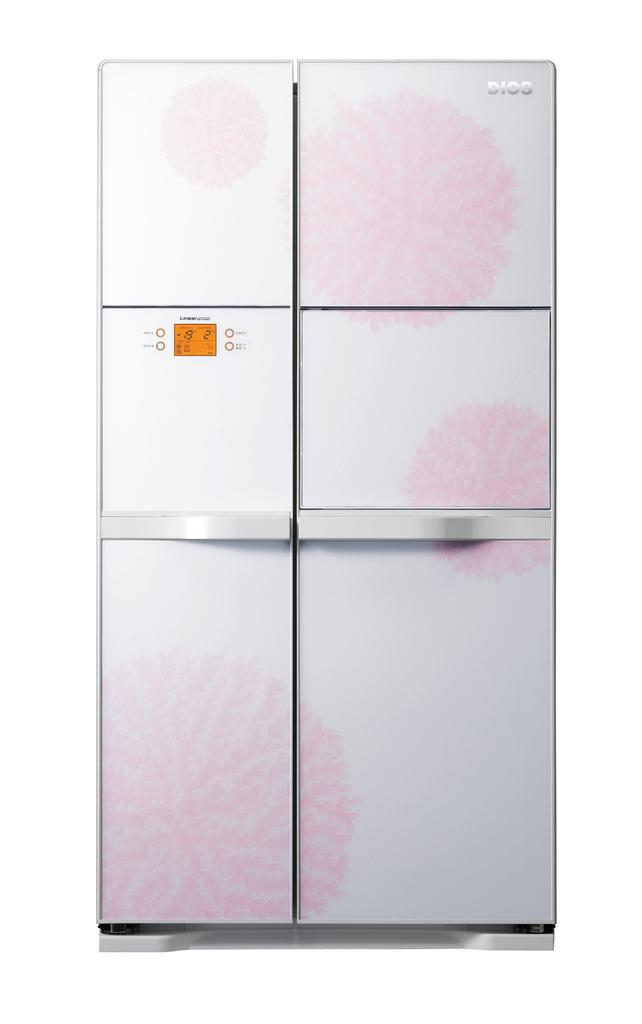What is the main object in the foreground of the image? There is a refrigerator in the foreground of the image. What color is the background of the image? The background of the image is white. What type of battle is taking place in the image? There is no battle present in the image; it only features a refrigerator in the foreground and a white background. How many tomatoes can be seen in the image? There are no tomatoes present in the image. 